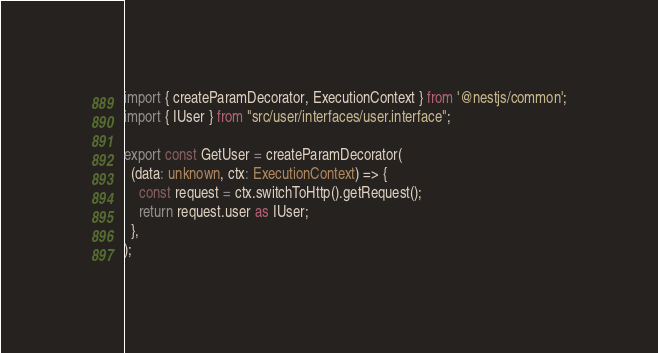Convert code to text. <code><loc_0><loc_0><loc_500><loc_500><_TypeScript_>import { createParamDecorator, ExecutionContext } from '@nestjs/common';
import { IUser } from "src/user/interfaces/user.interface";

export const GetUser = createParamDecorator(
  (data: unknown, ctx: ExecutionContext) => {
    const request = ctx.switchToHttp().getRequest();
    return request.user as IUser;
  },
);</code> 